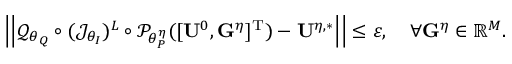Convert formula to latex. <formula><loc_0><loc_0><loc_500><loc_500>{ \left | \left | \mathcal { Q } _ { \theta _ { Q } } \circ ( \mathcal { J } _ { \theta _ { I } } ) ^ { L } \circ \mathcal { P } _ { \theta _ { P } ^ { \eta } } ( [ U ^ { 0 } , G ^ { \eta } ] ^ { T } ) - U ^ { \eta , * } \right | \right | } \leq \varepsilon , \quad \forall G ^ { \eta } \in \mathbb { R } ^ { M } .</formula> 